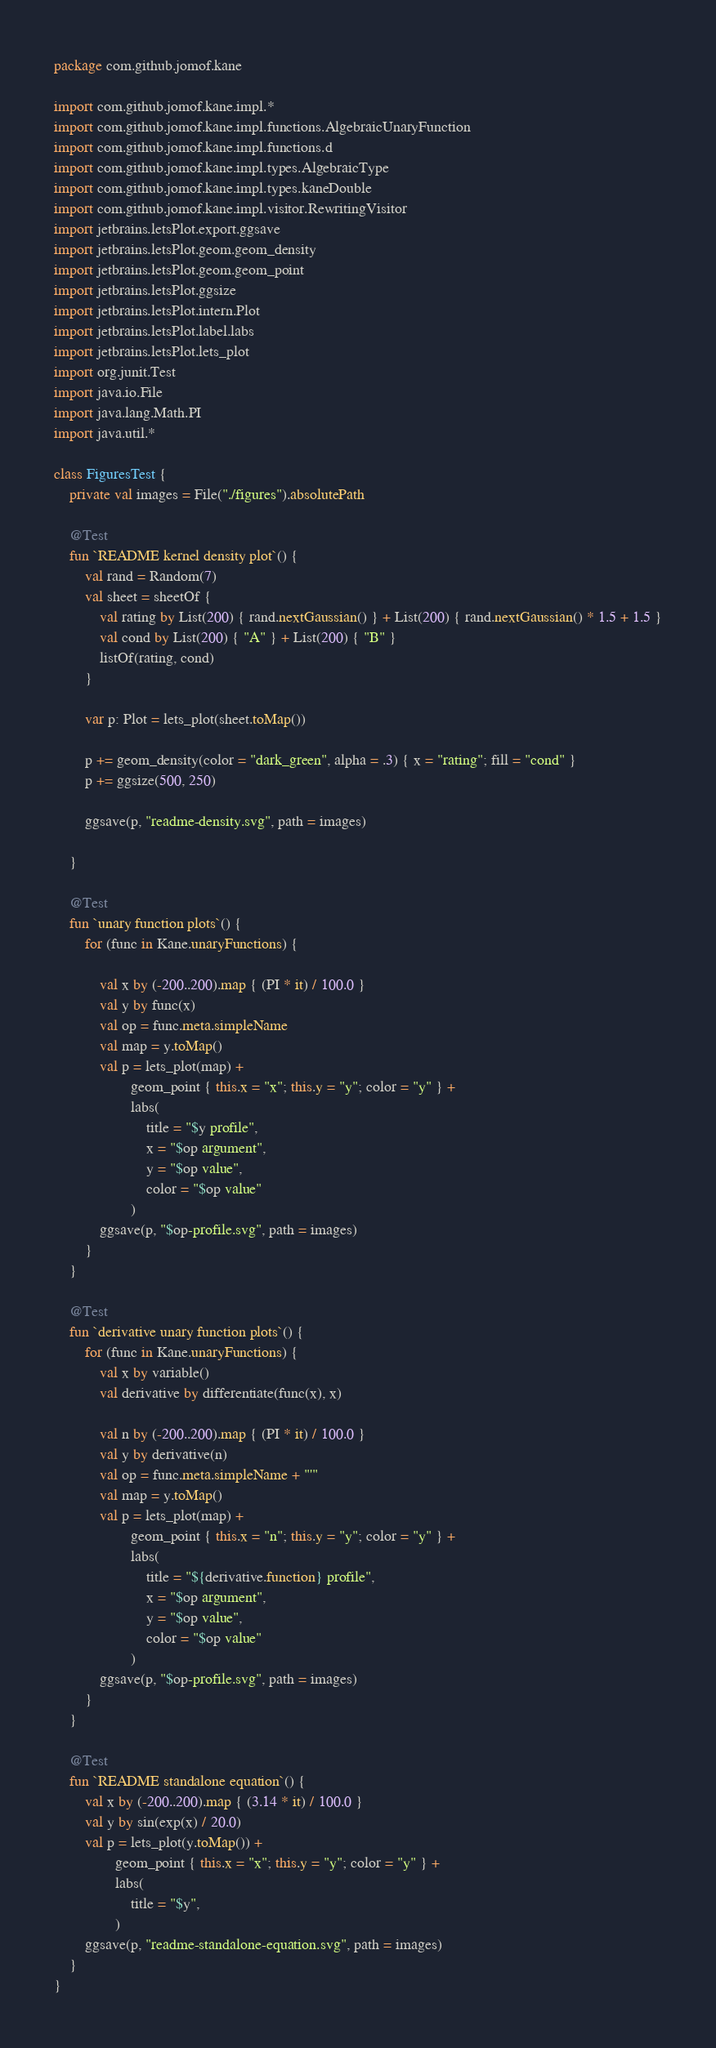Convert code to text. <code><loc_0><loc_0><loc_500><loc_500><_Kotlin_>package com.github.jomof.kane

import com.github.jomof.kane.impl.*
import com.github.jomof.kane.impl.functions.AlgebraicUnaryFunction
import com.github.jomof.kane.impl.functions.d
import com.github.jomof.kane.impl.types.AlgebraicType
import com.github.jomof.kane.impl.types.kaneDouble
import com.github.jomof.kane.impl.visitor.RewritingVisitor
import jetbrains.letsPlot.export.ggsave
import jetbrains.letsPlot.geom.geom_density
import jetbrains.letsPlot.geom.geom_point
import jetbrains.letsPlot.ggsize
import jetbrains.letsPlot.intern.Plot
import jetbrains.letsPlot.label.labs
import jetbrains.letsPlot.lets_plot
import org.junit.Test
import java.io.File
import java.lang.Math.PI
import java.util.*

class FiguresTest {
    private val images = File("./figures").absolutePath

    @Test
    fun `README kernel density plot`() {
        val rand = Random(7)
        val sheet = sheetOf {
            val rating by List(200) { rand.nextGaussian() } + List(200) { rand.nextGaussian() * 1.5 + 1.5 }
            val cond by List(200) { "A" } + List(200) { "B" }
            listOf(rating, cond)
        }

        var p: Plot = lets_plot(sheet.toMap())

        p += geom_density(color = "dark_green", alpha = .3) { x = "rating"; fill = "cond" }
        p += ggsize(500, 250)

        ggsave(p, "readme-density.svg", path = images)

    }

    @Test
    fun `unary function plots`() {
        for (func in Kane.unaryFunctions) {

            val x by (-200..200).map { (PI * it) / 100.0 }
            val y by func(x)
            val op = func.meta.simpleName
            val map = y.toMap()
            val p = lets_plot(map) +
                    geom_point { this.x = "x"; this.y = "y"; color = "y" } +
                    labs(
                        title = "$y profile",
                        x = "$op argument",
                        y = "$op value",
                        color = "$op value"
                    )
            ggsave(p, "$op-profile.svg", path = images)
        }
    }

    @Test
    fun `derivative unary function plots`() {
        for (func in Kane.unaryFunctions) {
            val x by variable()
            val derivative by differentiate(func(x), x)

            val n by (-200..200).map { (PI * it) / 100.0 }
            val y by derivative(n)
            val op = func.meta.simpleName + "'"
            val map = y.toMap()
            val p = lets_plot(map) +
                    geom_point { this.x = "n"; this.y = "y"; color = "y" } +
                    labs(
                        title = "${derivative.function} profile",
                        x = "$op argument",
                        y = "$op value",
                        color = "$op value"
                    )
            ggsave(p, "$op-profile.svg", path = images)
        }
    }

    @Test
    fun `README standalone equation`() {
        val x by (-200..200).map { (3.14 * it) / 100.0 }
        val y by sin(exp(x) / 20.0)
        val p = lets_plot(y.toMap()) +
                geom_point { this.x = "x"; this.y = "y"; color = "y" } +
                labs(
                    title = "$y",
                )
        ggsave(p, "readme-standalone-equation.svg", path = images)
    }
}</code> 